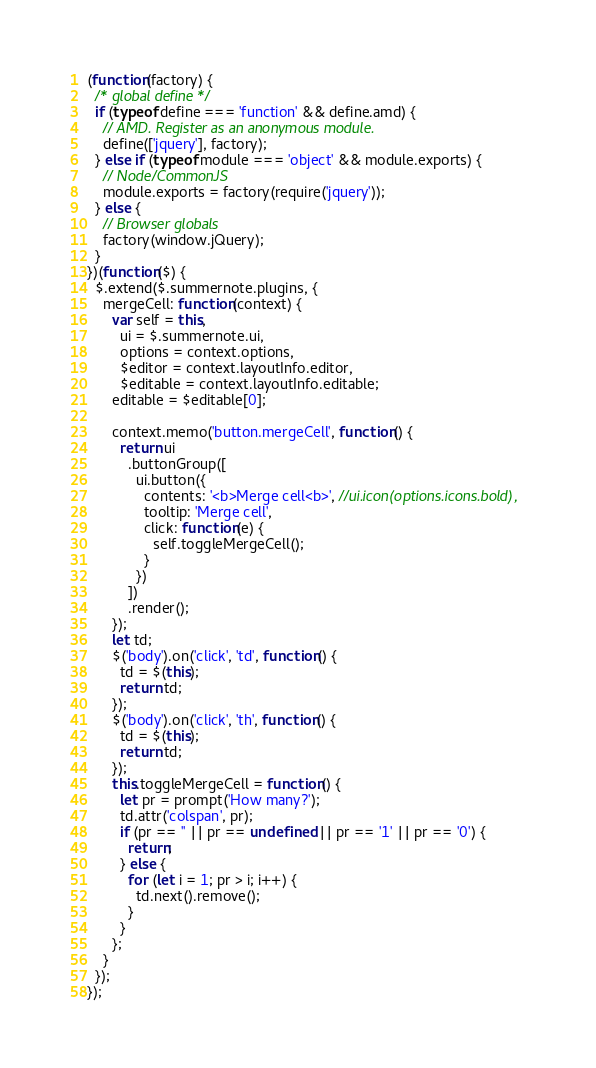Convert code to text. <code><loc_0><loc_0><loc_500><loc_500><_JavaScript_>(function(factory) {
  /* global define */
  if (typeof define === 'function' && define.amd) {
    // AMD. Register as an anonymous module.
    define(['jquery'], factory);
  } else if (typeof module === 'object' && module.exports) {
    // Node/CommonJS
    module.exports = factory(require('jquery'));
  } else {
    // Browser globals
    factory(window.jQuery);
  }
})(function($) {
  $.extend($.summernote.plugins, {
    mergeCell: function(context) {
      var self = this,
        ui = $.summernote.ui,
        options = context.options,
        $editor = context.layoutInfo.editor,
        $editable = context.layoutInfo.editable;
      editable = $editable[0];

      context.memo('button.mergeCell', function() {
        return ui
          .buttonGroup([
            ui.button({
              contents: '<b>Merge cell<b>', //ui.icon(options.icons.bold),
              tooltip: 'Merge cell',
              click: function(e) {
                self.toggleMergeCell();
              }
            })
          ])
          .render();
      });
      let td;
      $('body').on('click', 'td', function() {
        td = $(this);
        return td;
      });
      $('body').on('click', 'th', function() {
        td = $(this);
        return td;
      });
      this.toggleMergeCell = function() {
        let pr = prompt('How many?');
        td.attr('colspan', pr);
        if (pr == '' || pr == undefined || pr == '1' || pr == '0') {
          return;
        } else {
          for (let i = 1; pr > i; i++) {
            td.next().remove();
          }
        }
      };
    }
  });
});
</code> 